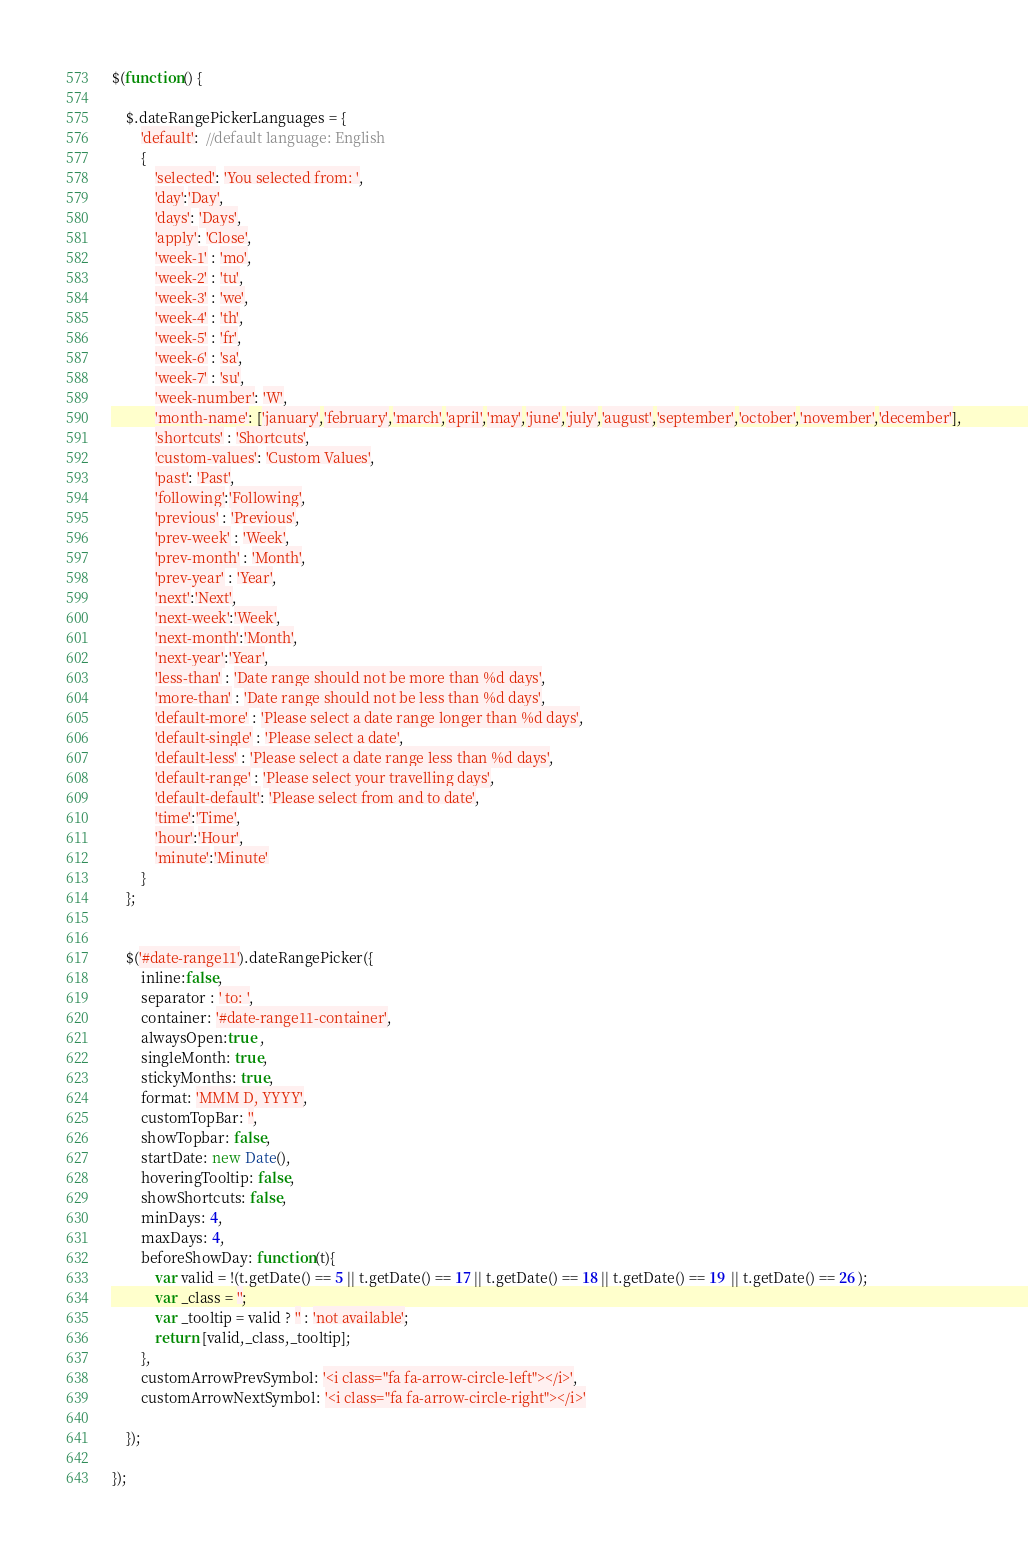<code> <loc_0><loc_0><loc_500><loc_500><_JavaScript_>$(function() {

	$.dateRangePickerLanguages = {
		'default':  //default language: English
		{
			'selected': 'You selected from: ',
			'day':'Day',
			'days': 'Days',
			'apply': 'Close',
			'week-1' : 'mo',
			'week-2' : 'tu',
			'week-3' : 'we',
			'week-4' : 'th',
			'week-5' : 'fr',
			'week-6' : 'sa',
			'week-7' : 'su',
			'week-number': 'W',
			'month-name': ['january','february','march','april','may','june','july','august','september','october','november','december'],
			'shortcuts' : 'Shortcuts',
			'custom-values': 'Custom Values',
			'past': 'Past',
			'following':'Following',
			'previous' : 'Previous',
			'prev-week' : 'Week',
			'prev-month' : 'Month',
			'prev-year' : 'Year',
			'next':'Next',
			'next-week':'Week',
			'next-month':'Month',
			'next-year':'Year',
			'less-than' : 'Date range should not be more than %d days',
			'more-than' : 'Date range should not be less than %d days',
			'default-more' : 'Please select a date range longer than %d days',
			'default-single' : 'Please select a date',
			'default-less' : 'Please select a date range less than %d days',
			'default-range' : 'Please select your travelling days',
			'default-default': 'Please select from and to date',
			'time':'Time',
			'hour':'Hour',
			'minute':'Minute'
		}
	};

	
	$('#date-range11').dateRangePicker({
		inline:false,
		separator : ' to: ',
		container: '#date-range11-container', 
		alwaysOpen:true ,
		singleMonth: true,
		stickyMonths: true,
		format: 'MMM D, YYYY',
		customTopBar: '',
		showTopbar: false,
		startDate: new Date(),
		hoveringTooltip: false,
		showShortcuts: false,
		minDays: 4,
		maxDays: 4,
		beforeShowDay: function(t){
			var valid = !(t.getDate() == 5 || t.getDate() == 17 || t.getDate() == 18 || t.getDate() == 19  || t.getDate() == 26 );
			var _class = '';
			var _tooltip = valid ? '' : 'not available';
			return [valid,_class,_tooltip];
		},
		customArrowPrevSymbol: '<i class="fa fa-arrow-circle-left"></i>',
		customArrowNextSymbol: '<i class="fa fa-arrow-circle-right"></i>'
		
	});
	
});</code> 